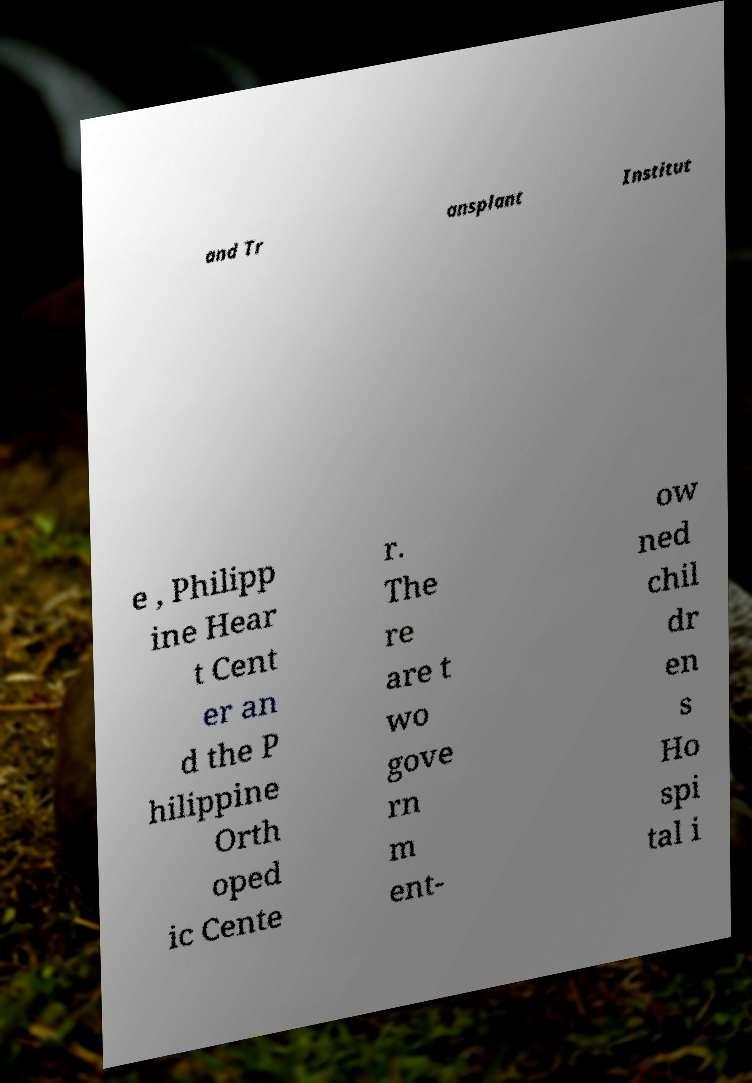There's text embedded in this image that I need extracted. Can you transcribe it verbatim? and Tr ansplant Institut e , Philipp ine Hear t Cent er an d the P hilippine Orth oped ic Cente r. The re are t wo gove rn m ent- ow ned chil dr en s Ho spi tal i 